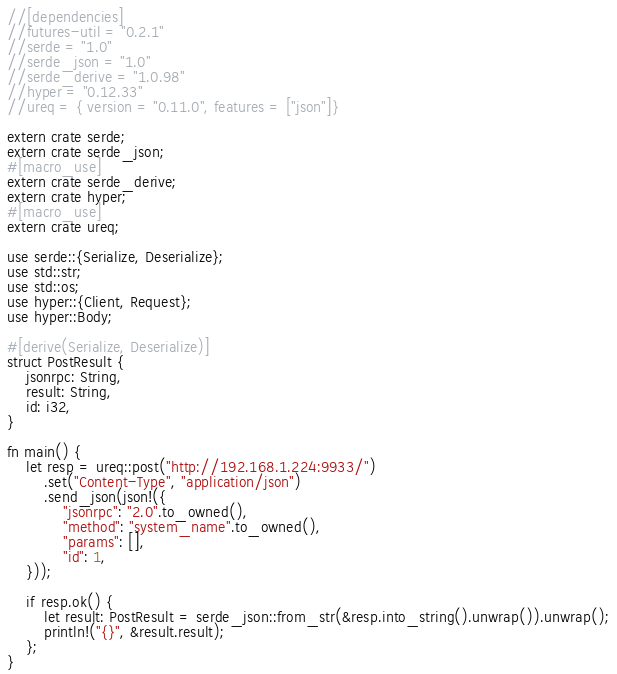Convert code to text. <code><loc_0><loc_0><loc_500><loc_500><_Rust_>//[dependencies]
//futures-util = "0.2.1"
//serde = "1.0"
//serde_json = "1.0"
//serde_derive = "1.0.98"
//hyper = "0.12.33"
//ureq = { version = "0.11.0", features = ["json"]}

extern crate serde;
extern crate serde_json;
#[macro_use]
extern crate serde_derive;
extern crate hyper;
#[macro_use]
extern crate ureq;

use serde::{Serialize, Deserialize};
use std::str;
use std::os;
use hyper::{Client, Request};
use hyper::Body;

#[derive(Serialize, Deserialize)]
struct PostResult {
    jsonrpc: String,
    result: String,
    id: i32,
}

fn main() {
    let resp = ureq::post("http://192.168.1.224:9933/")
        .set("Content-Type", "application/json")
        .send_json(json!({
            "jsonrpc": "2.0".to_owned(),
            "method": "system_name".to_owned(),
            "params": [],
            "id": 1,
    }));

    if resp.ok() {
        let result: PostResult = serde_json::from_str(&resp.into_string().unwrap()).unwrap();
        println!("{}", &result.result);
    };
}
</code> 